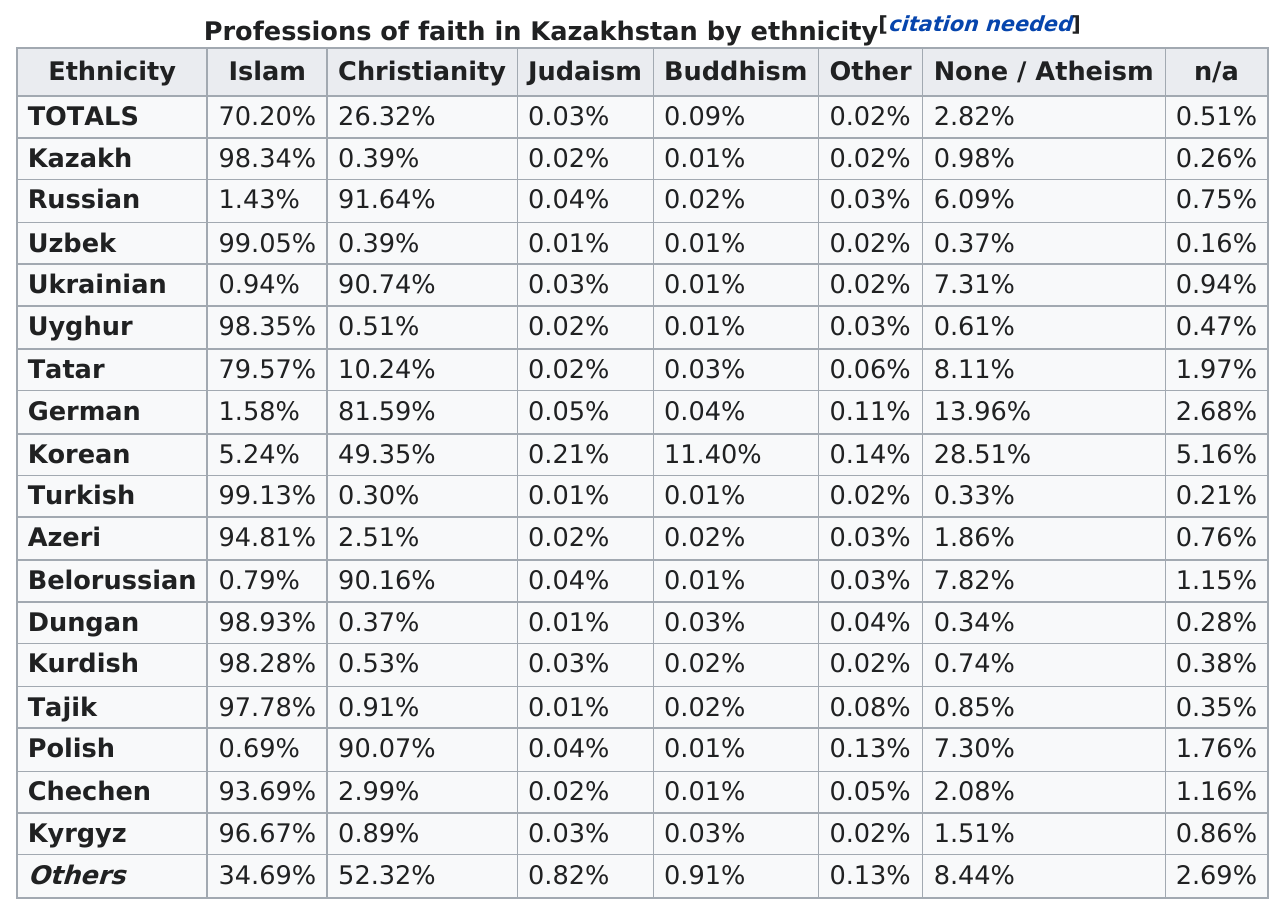Give some essential details in this illustration. The Dungan ethnicity has the fewest number of atheists after the Turkish. Each religion is listed only once. The ethnicity with the most Islam professions of faith is Turkish. According to a study, the ethnicity that has the most followers of atheism is Korean. The Tatar ethnicity is higher than that of Germans. 